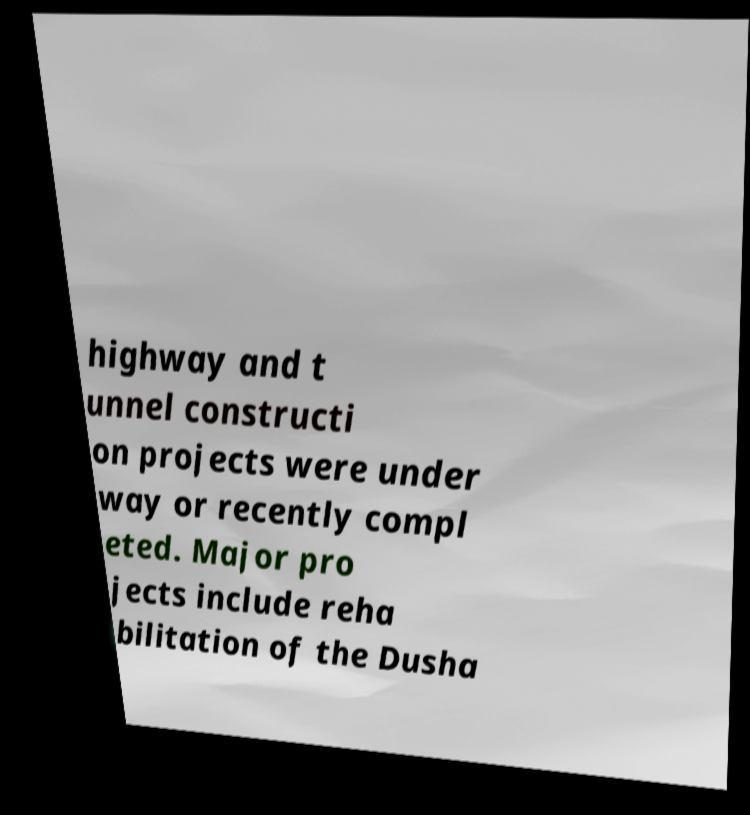Please read and relay the text visible in this image. What does it say? highway and t unnel constructi on projects were under way or recently compl eted. Major pro jects include reha bilitation of the Dusha 